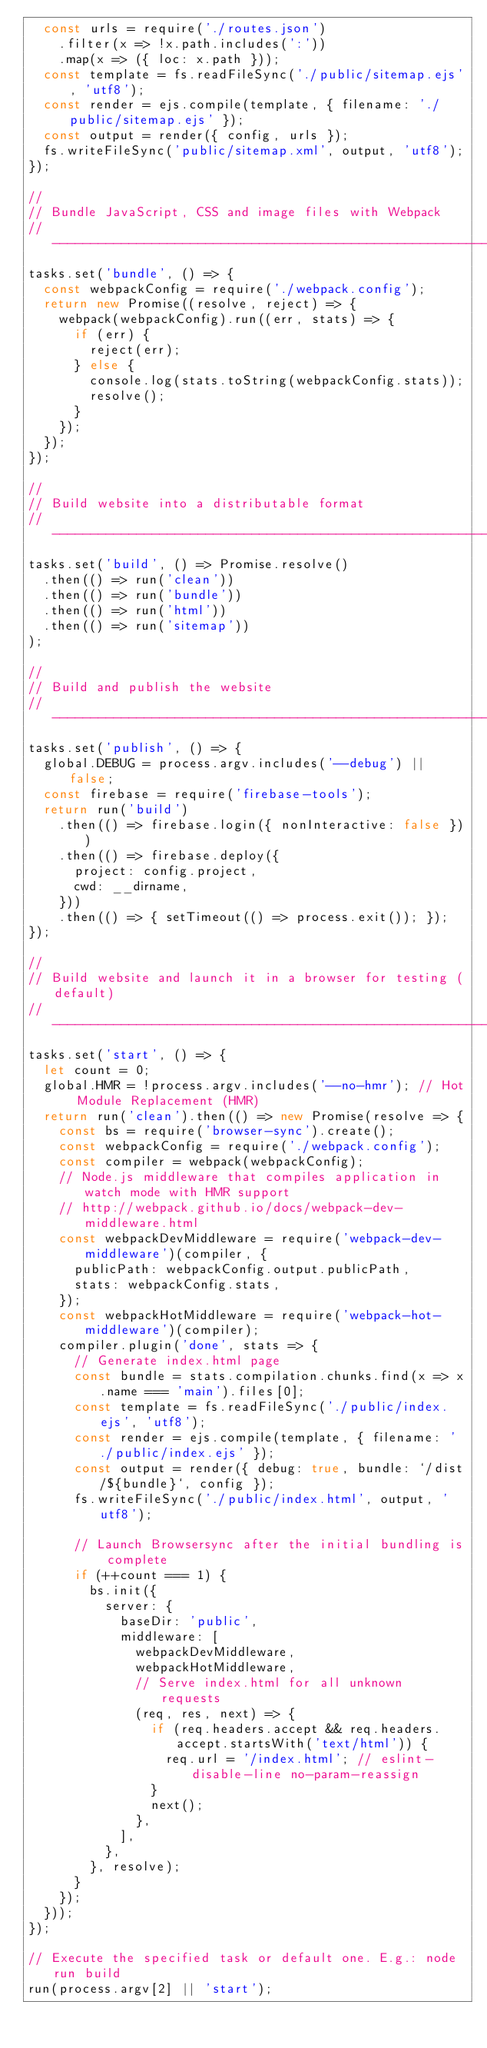<code> <loc_0><loc_0><loc_500><loc_500><_JavaScript_>  const urls = require('./routes.json')
    .filter(x => !x.path.includes(':'))
    .map(x => ({ loc: x.path }));
  const template = fs.readFileSync('./public/sitemap.ejs', 'utf8');
  const render = ejs.compile(template, { filename: './public/sitemap.ejs' });
  const output = render({ config, urls });
  fs.writeFileSync('public/sitemap.xml', output, 'utf8');
});

//
// Bundle JavaScript, CSS and image files with Webpack
// -----------------------------------------------------------------------------
tasks.set('bundle', () => {
  const webpackConfig = require('./webpack.config');
  return new Promise((resolve, reject) => {
    webpack(webpackConfig).run((err, stats) => {
      if (err) {
        reject(err);
      } else {
        console.log(stats.toString(webpackConfig.stats));
        resolve();
      }
    });
  });
});

//
// Build website into a distributable format
// -----------------------------------------------------------------------------
tasks.set('build', () => Promise.resolve()
  .then(() => run('clean'))
  .then(() => run('bundle'))
  .then(() => run('html'))
  .then(() => run('sitemap'))
);

//
// Build and publish the website
// -----------------------------------------------------------------------------
tasks.set('publish', () => {
  global.DEBUG = process.argv.includes('--debug') || false;
  const firebase = require('firebase-tools');
  return run('build')
    .then(() => firebase.login({ nonInteractive: false }))
    .then(() => firebase.deploy({
      project: config.project,
      cwd: __dirname,
    }))
    .then(() => { setTimeout(() => process.exit()); });
});

//
// Build website and launch it in a browser for testing (default)
// -----------------------------------------------------------------------------
tasks.set('start', () => {
  let count = 0;
  global.HMR = !process.argv.includes('--no-hmr'); // Hot Module Replacement (HMR)
  return run('clean').then(() => new Promise(resolve => {
    const bs = require('browser-sync').create();
    const webpackConfig = require('./webpack.config');
    const compiler = webpack(webpackConfig);
    // Node.js middleware that compiles application in watch mode with HMR support
    // http://webpack.github.io/docs/webpack-dev-middleware.html
    const webpackDevMiddleware = require('webpack-dev-middleware')(compiler, {
      publicPath: webpackConfig.output.publicPath,
      stats: webpackConfig.stats,
    });
    const webpackHotMiddleware = require('webpack-hot-middleware')(compiler);
    compiler.plugin('done', stats => {
      // Generate index.html page
      const bundle = stats.compilation.chunks.find(x => x.name === 'main').files[0];
      const template = fs.readFileSync('./public/index.ejs', 'utf8');
      const render = ejs.compile(template, { filename: './public/index.ejs' });
      const output = render({ debug: true, bundle: `/dist/${bundle}`, config });
      fs.writeFileSync('./public/index.html', output, 'utf8');

      // Launch Browsersync after the initial bundling is complete
      if (++count === 1) {
        bs.init({
          server: {
            baseDir: 'public',
            middleware: [
              webpackDevMiddleware,
              webpackHotMiddleware,
              // Serve index.html for all unknown requests
              (req, res, next) => {
                if (req.headers.accept && req.headers.accept.startsWith('text/html')) {
                  req.url = '/index.html'; // eslint-disable-line no-param-reassign
                }
                next();
              },
            ],
          },
        }, resolve);
      }
    });
  }));
});

// Execute the specified task or default one. E.g.: node run build
run(process.argv[2] || 'start');
</code> 